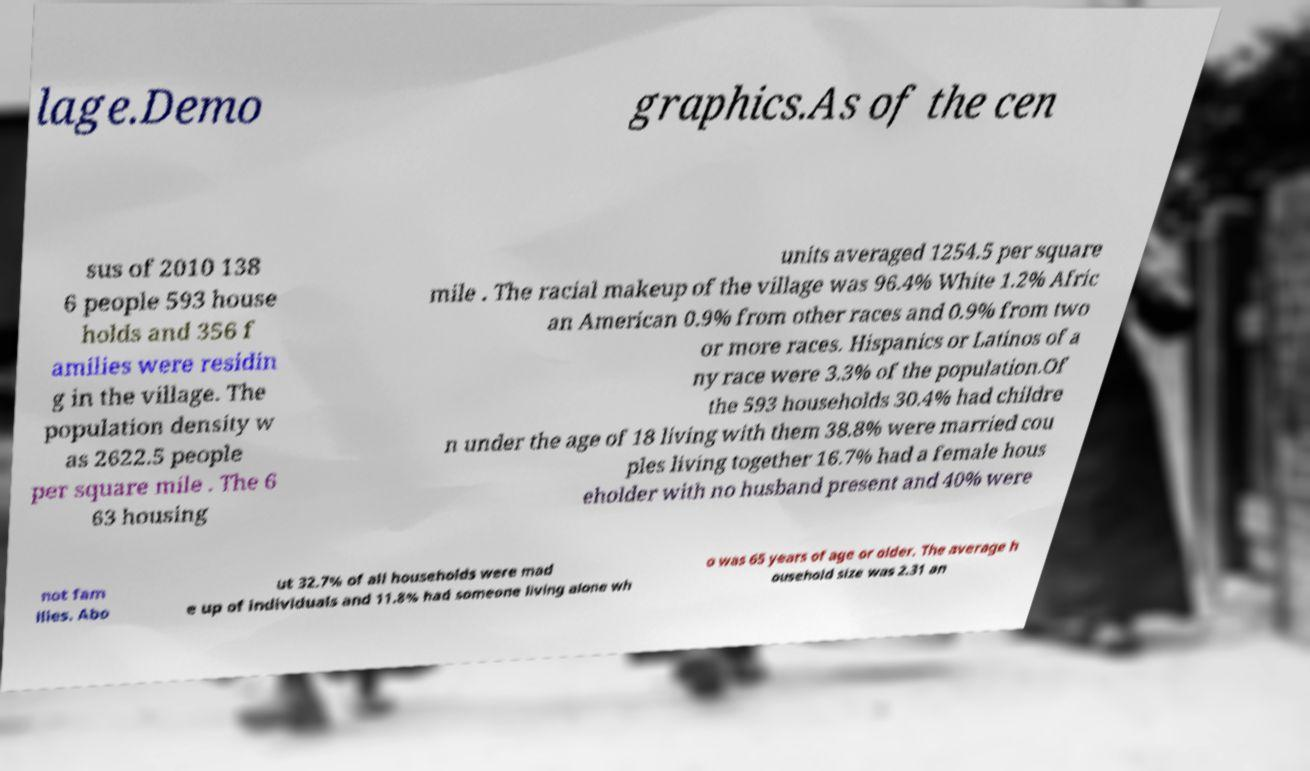Can you accurately transcribe the text from the provided image for me? lage.Demo graphics.As of the cen sus of 2010 138 6 people 593 house holds and 356 f amilies were residin g in the village. The population density w as 2622.5 people per square mile . The 6 63 housing units averaged 1254.5 per square mile . The racial makeup of the village was 96.4% White 1.2% Afric an American 0.9% from other races and 0.9% from two or more races. Hispanics or Latinos of a ny race were 3.3% of the population.Of the 593 households 30.4% had childre n under the age of 18 living with them 38.8% were married cou ples living together 16.7% had a female hous eholder with no husband present and 40% were not fam ilies. Abo ut 32.7% of all households were mad e up of individuals and 11.8% had someone living alone wh o was 65 years of age or older. The average h ousehold size was 2.31 an 